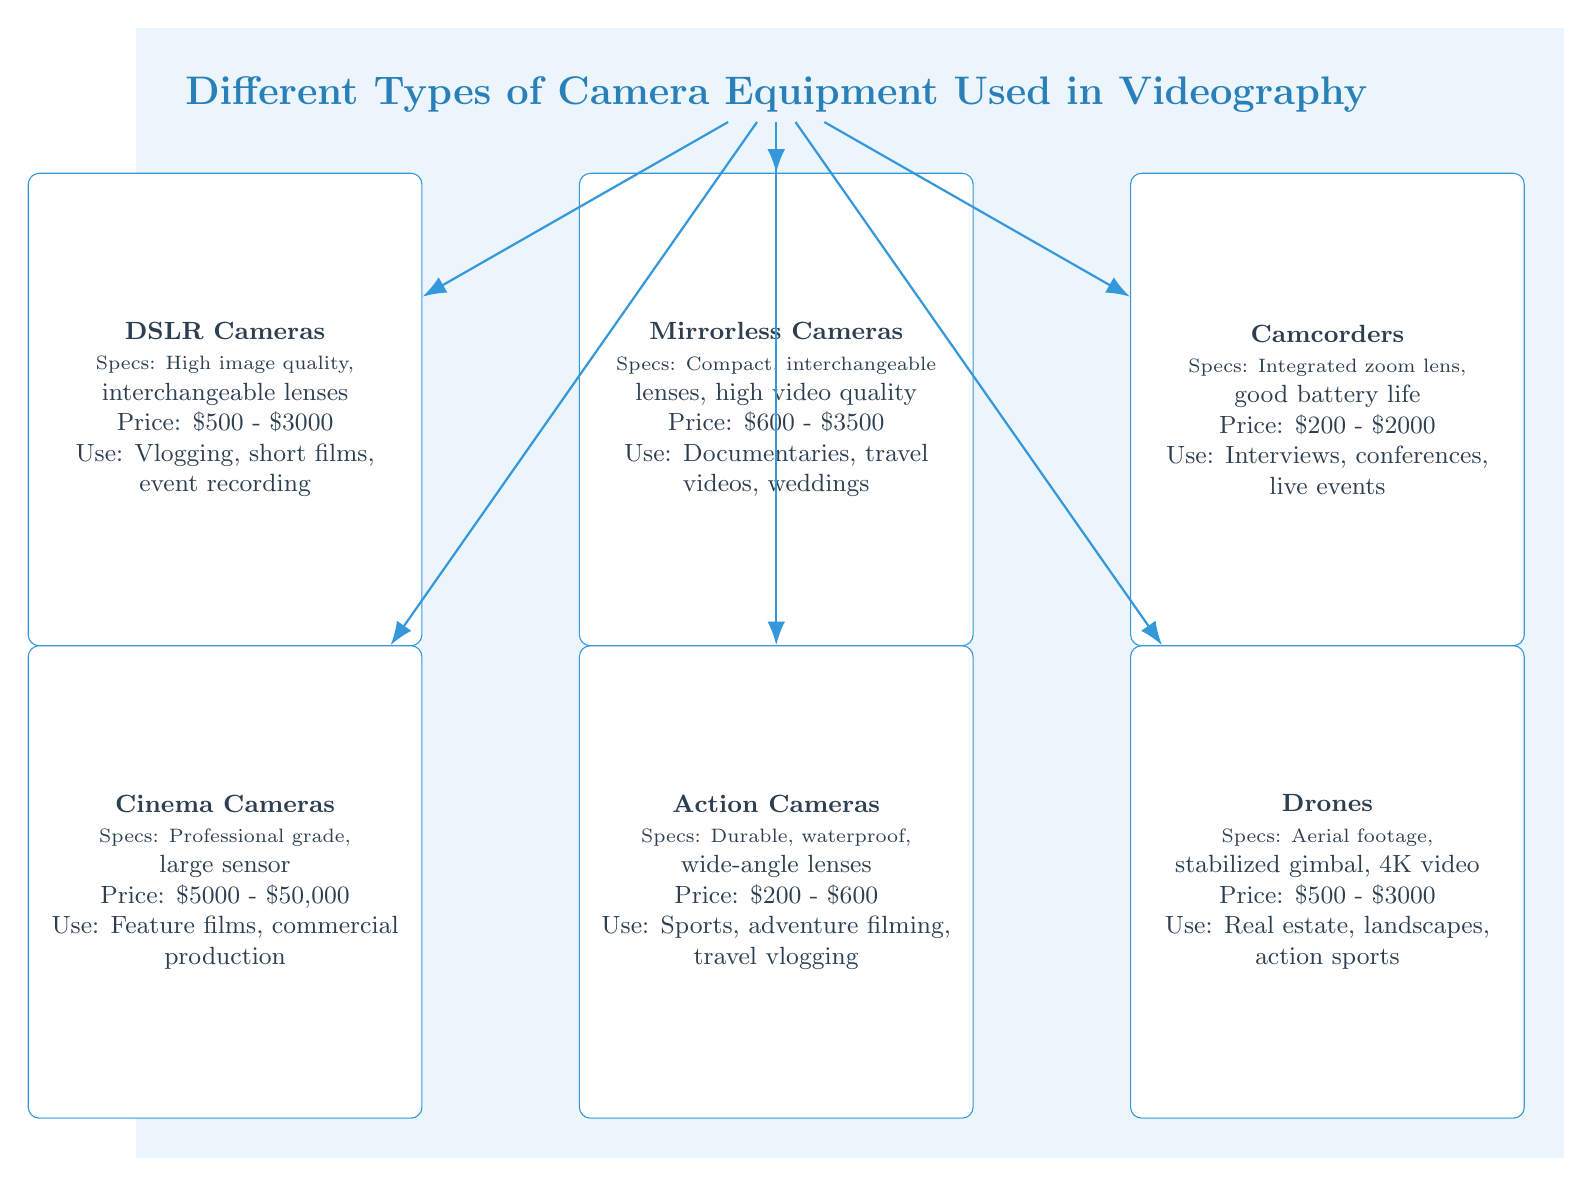What types of cameras are listed in the diagram? The diagram lists six types of cameras: DSLR Cameras, Mirrorless Cameras, Camcorders, Cinema Cameras, Action Cameras, and Drones.
Answer: DSLR Cameras, Mirrorless Cameras, Camcorders, Cinema Cameras, Action Cameras, Drones What is the price range of Camcorders? The price range for Camcorders, as shown in the diagram, is \$200 - \$2000.
Answer: \$200 - \$2000 Which type of camera is best for vlogging? According to the diagram, DSLR Cameras are best for vlogging.
Answer: DSLR Cameras What specifications do Mirrorless Cameras have? The diagram states that Mirrorless Cameras are compact, have interchangeable lenses, and provide high video quality.
Answer: Compact, interchangeable lenses, high video quality Which camera type has the highest price range? The diagram indicates that Cinema Cameras have the highest price range, from \$5000 to \$50,000.
Answer: \$5000 - \$50,000 How many types of camera equipment are depicted in the diagram? The diagram depicts six types of camera equipment used in videography.
Answer: Six Which camera is suitable for underwater filming? The diagram lists Action Cameras as suitable for underwater filming due to their durability and waterproof features.
Answer: Action Cameras What use case is associated with Drones? The diagram associates Drones with use cases like real estate, landscapes, and action sports.
Answer: Real estate, landscapes, action sports 